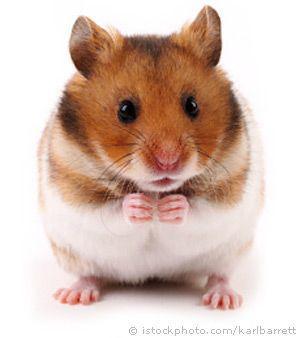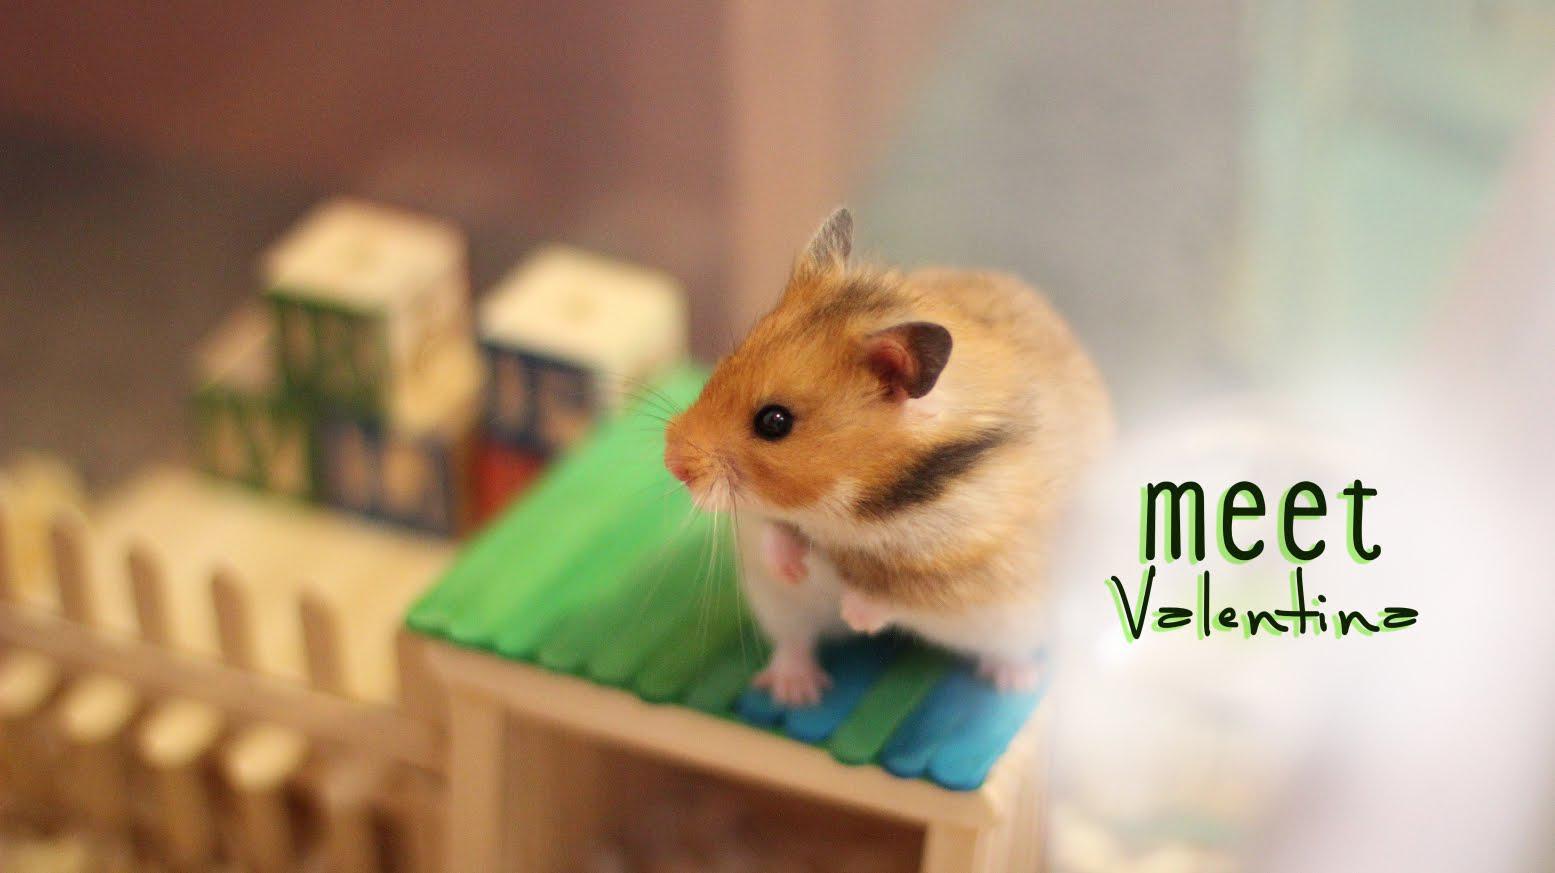The first image is the image on the left, the second image is the image on the right. For the images shown, is this caption "At least one of the rodents is outside." true? Answer yes or no. No. The first image is the image on the left, the second image is the image on the right. For the images displayed, is the sentence "The image on the left shows a single rodent standing on its back legs." factually correct? Answer yes or no. Yes. 